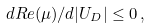Convert formula to latex. <formula><loc_0><loc_0><loc_500><loc_500>d R e ( \mu ) / d | U _ { D } | \leq 0 \, ,</formula> 